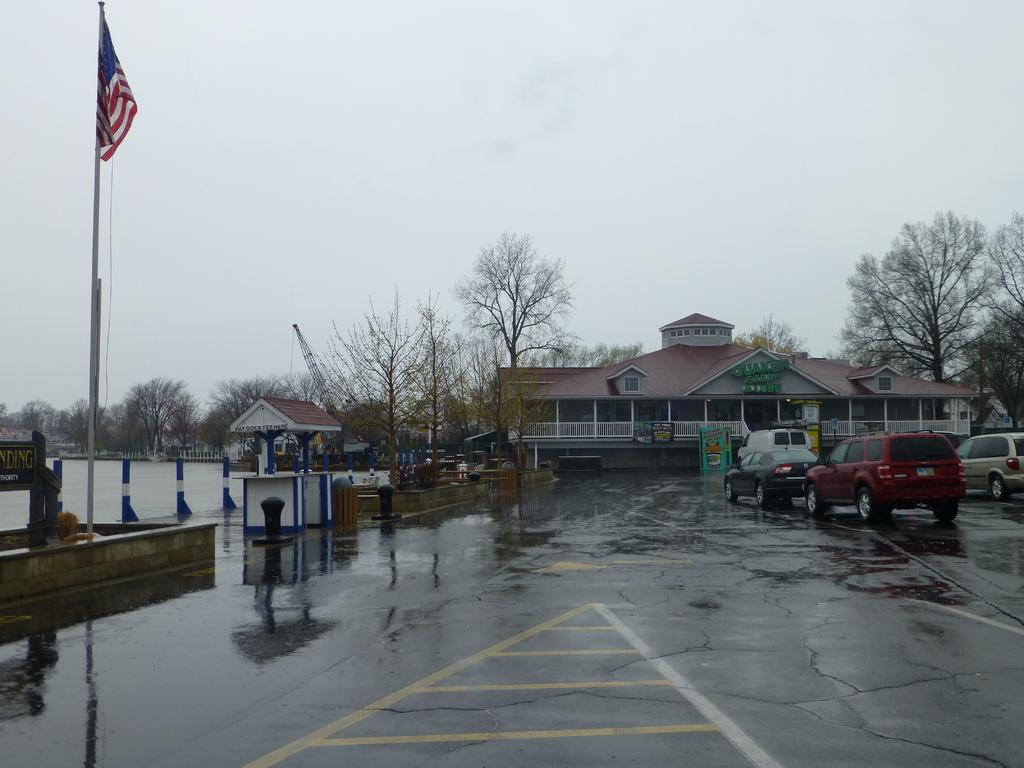What type of vehicles can be seen on the right side of the road in the image? There are cars on the right side of the road in the image. What structure is located in the middle of the image? There is a house in the middle of the image. What type of vegetation is on the left side of the image? There are trees on the left side of the image. Can you tell me how many pins are holding the house together in the image? There is no mention of pins in the image, and the house's construction is not visible. What type of pie is being served at the picnic in the image? There is no picnic or pie present in the image; it features cars, a house, and trees. 